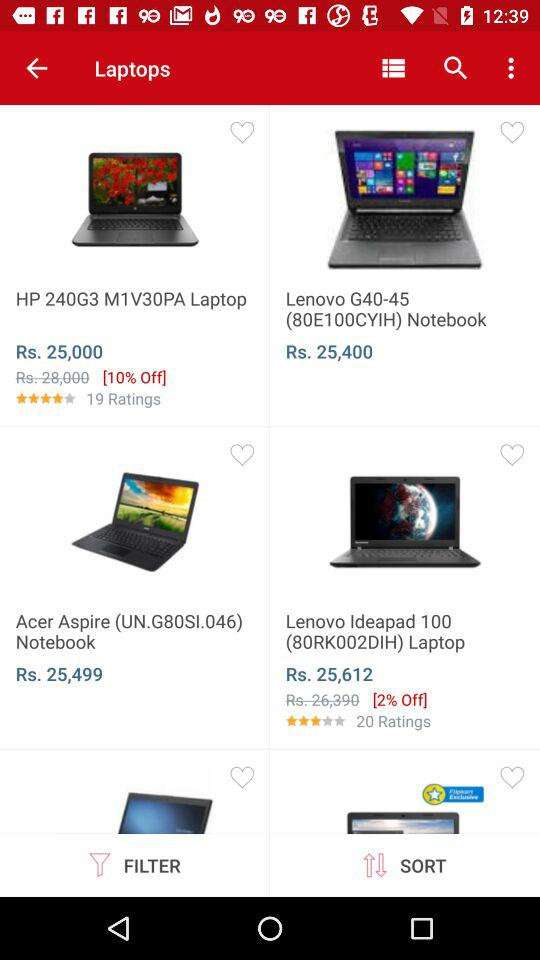What is the price of "Acer Aspire" laptop? The price of the "Acer Aspire" laptop is Rs. 25,499. 